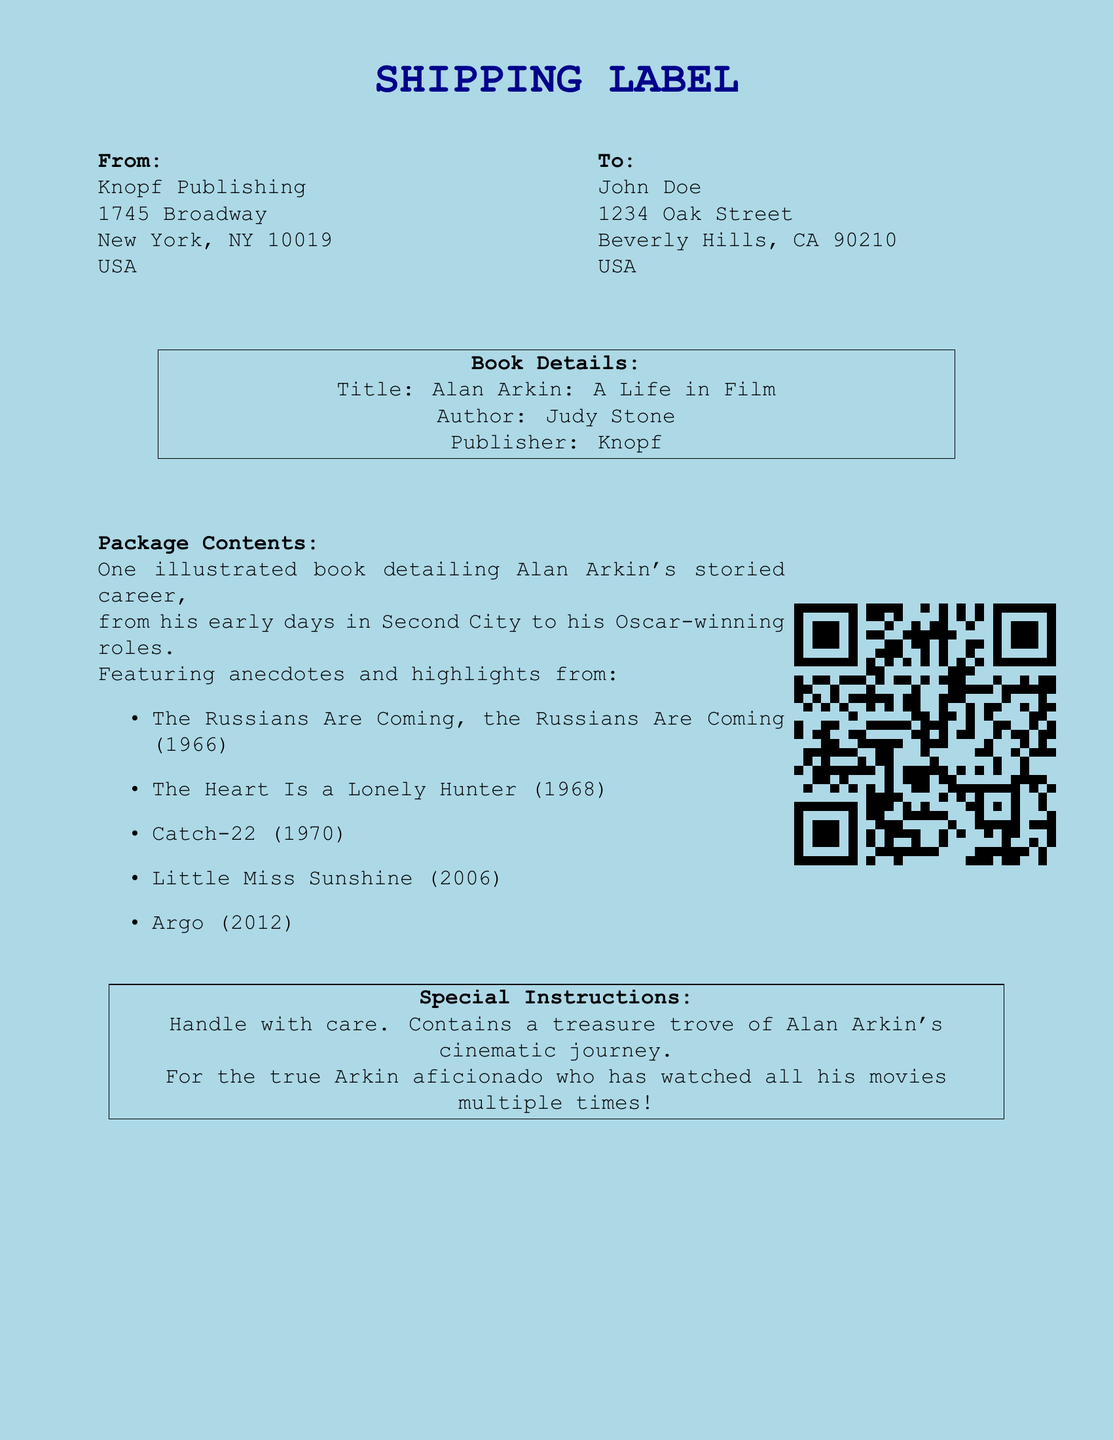What is the title of the book? The title of the book is mentioned in the document under "Book Details."
Answer: Alan Arkin: A Life in Film Who is the author of the book? The author's name is provided in the "Book Details" section of the document.
Answer: Judy Stone What is the name of the publisher? The publisher's name is included in the "Book Details" section of the document.
Answer: Knopf How many films are highlighted in the book? The number of films is determined by counting the list provided in the "Package Contents" section.
Answer: Five Which film was released in 2006? The specific film is noted in the list of highlighted films in the document.
Answer: Little Miss Sunshine What special instructions are given for the package? The special instructions are explicitly stated in the "Special Instructions" section of the document.
Answer: Handle with care Where is the book being shipped from? The "From" address section provides the information about where the book is being sent from.
Answer: Knopf Publishing Who is the recipient of the package? The "To" section details the name of the person receiving the package.
Answer: John Doe 